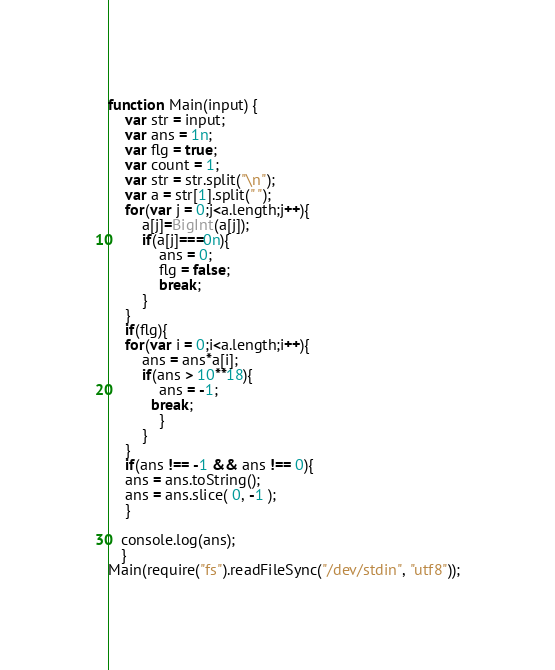Convert code to text. <code><loc_0><loc_0><loc_500><loc_500><_JavaScript_>function Main(input) {
	var str = input;
	var ans = 1n;
	var flg = true;
	var count = 1;
	var str = str.split("\n");
	var a = str[1].split(" ");
	for(var j = 0;j<a.length;j++){
		a[j]=BigInt(a[j]);
		if(a[j]===0n){
			ans = 0;
			flg = false;
			break;
		}
	}
	if(flg){
	for(var i = 0;i<a.length;i++){
		ans = ans*a[i];
		if(ans > 10**18){
			ans = -1;	
          break;
			}
    	}
    }
  	if(ans !== -1 && ans !== 0){
  	ans = ans.toString();
	ans = ans.slice( 0, -1 );
    }

   console.log(ans);
   }
Main(require("fs").readFileSync("/dev/stdin", "utf8"));</code> 